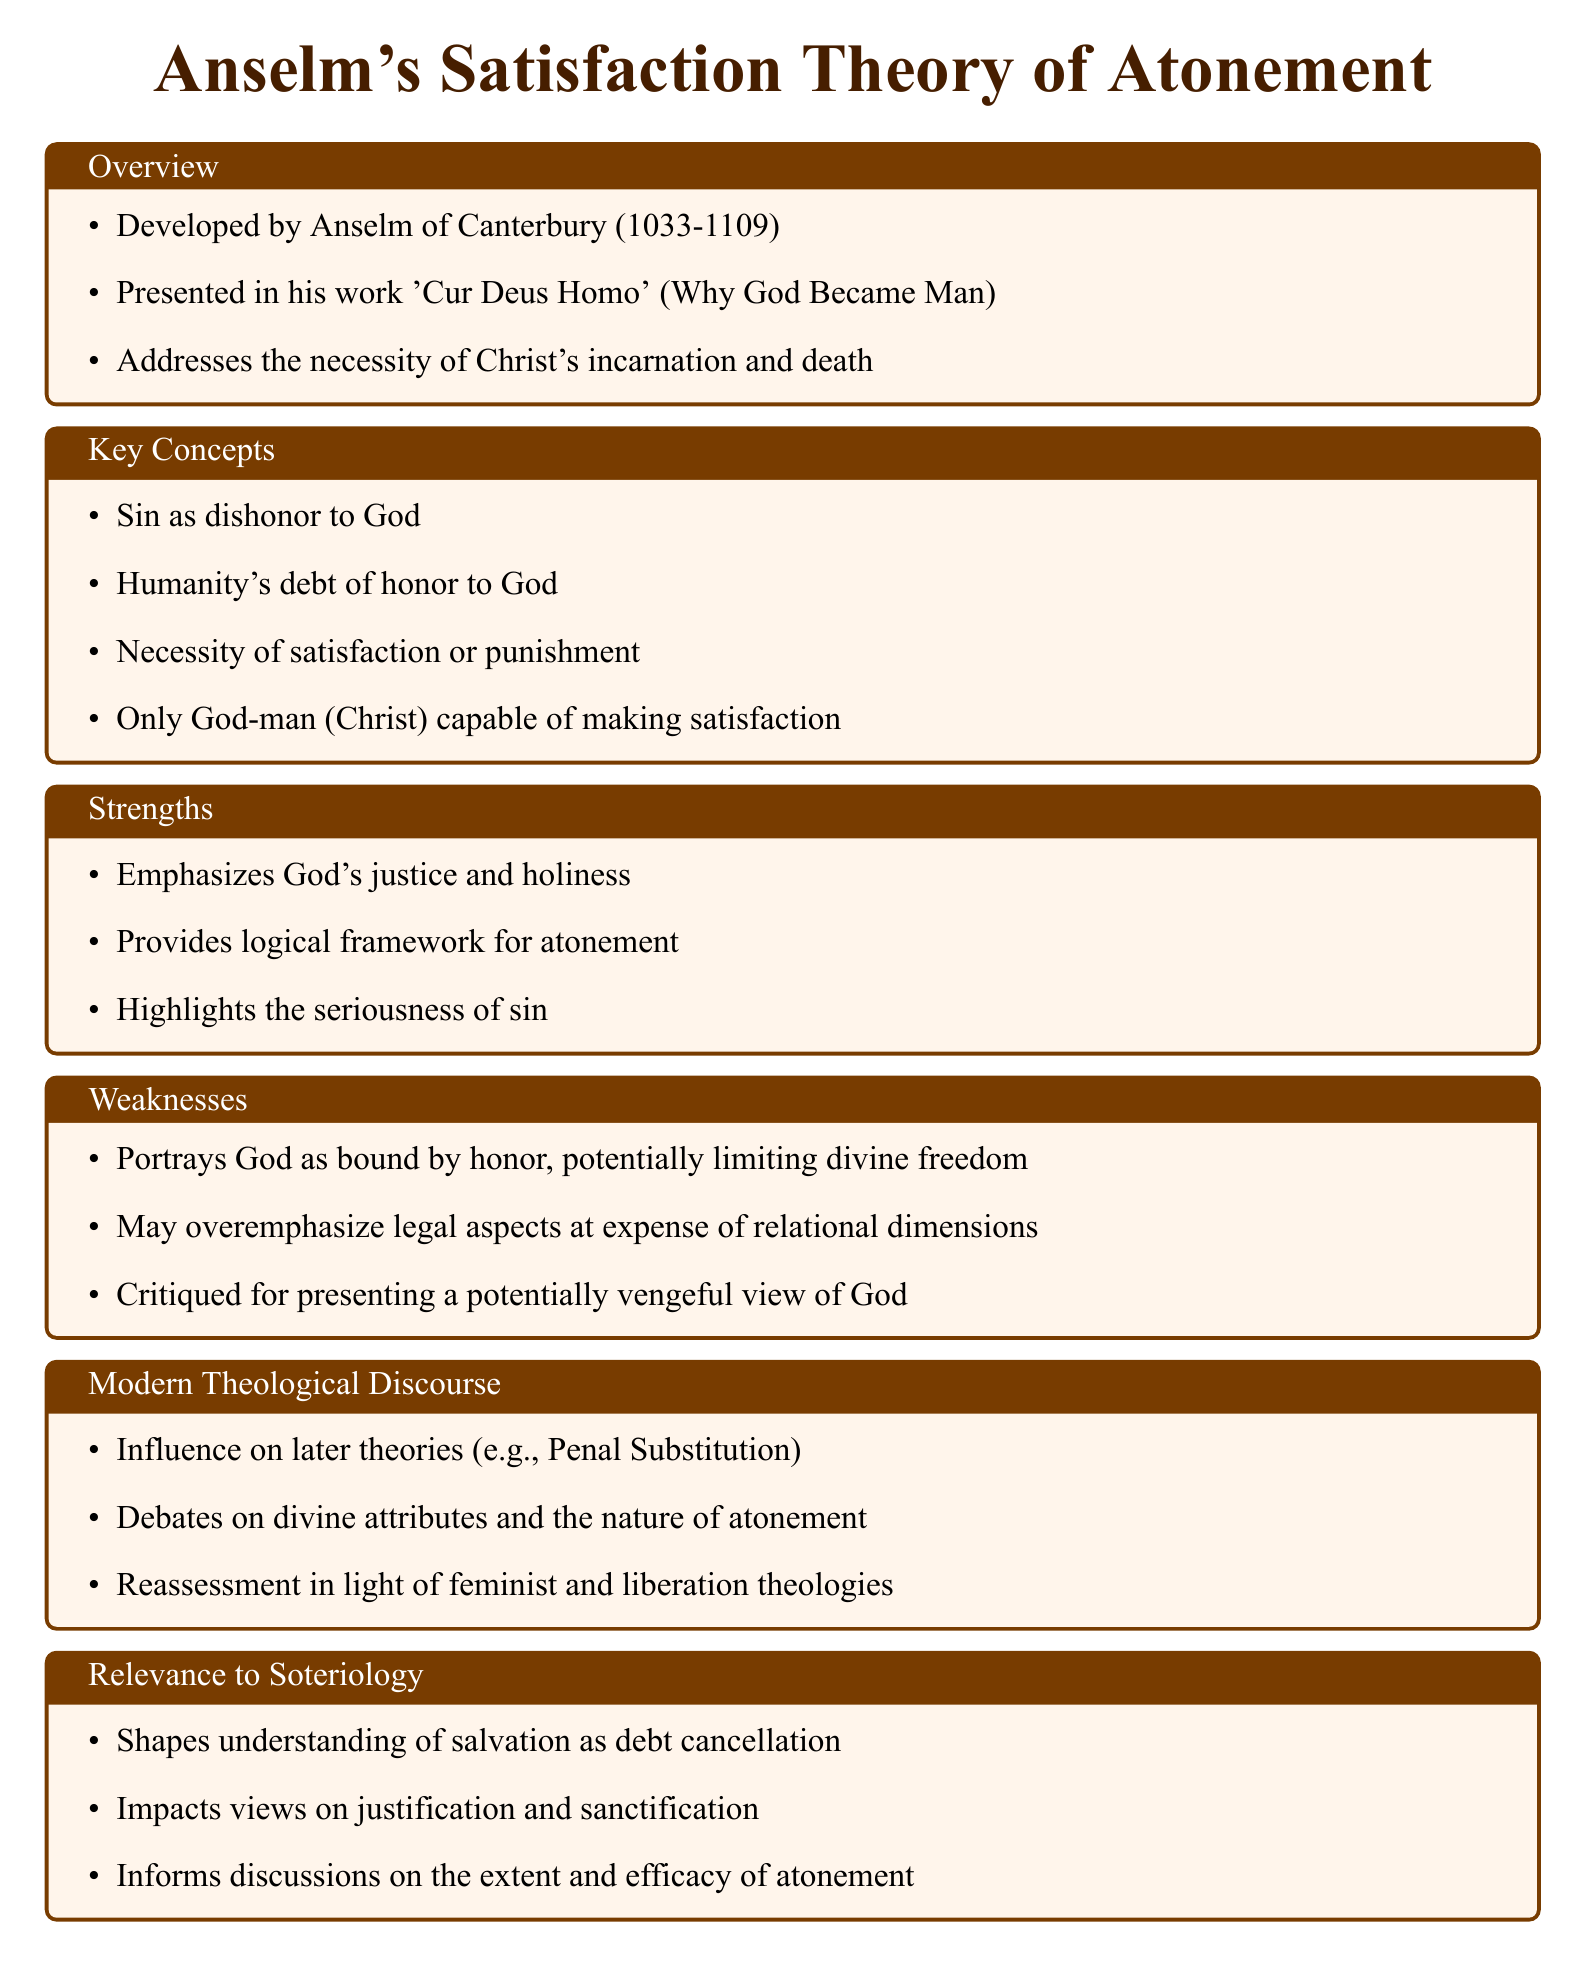What is the title of Anselm's work discussing his theory? The title refers to Anselm's book where he presents his satisfaction theory of atonement.
Answer: 'Cur Deus Homo' Who developed the Satisfaction Theory of Atonement? This question pertains to the individual who created this theological framework.
Answer: Anselm of Canterbury What is one key concept of Anselm's theory regarding sin? This concept reflects the nature of sin in relation to God, as stated in the document.
Answer: Dishonor to God List one strength of Anselm's theory. This question seeks one of the main positive aspects highlighted in the document.
Answer: Emphasizes God's justice and holiness Identify one weakness of Anselm's theory. This asks for one of the criticisms mentioned regarding Anselm's view of God.
Answer: Portrays God as bound by honor How many sections are in the notes? This question requires counting the distinct sections within the document for organization and structure understanding.
Answer: Six What aspect of modern theology has been influenced by Anselm's theory? This question addresses the impact of Anselm’s work on contemporary theological discussion.
Answer: Penal Substitution How does Anselm's theory shape views on salvation? This question explores how his satisfaction theory affects the understanding of salvation according to the document.
Answer: Debt cancellation What does Anselm's theory inform discussions about? This queries the broader implications of the theory as articulated in the notes.
Answer: Extent and efficacy of atonement 